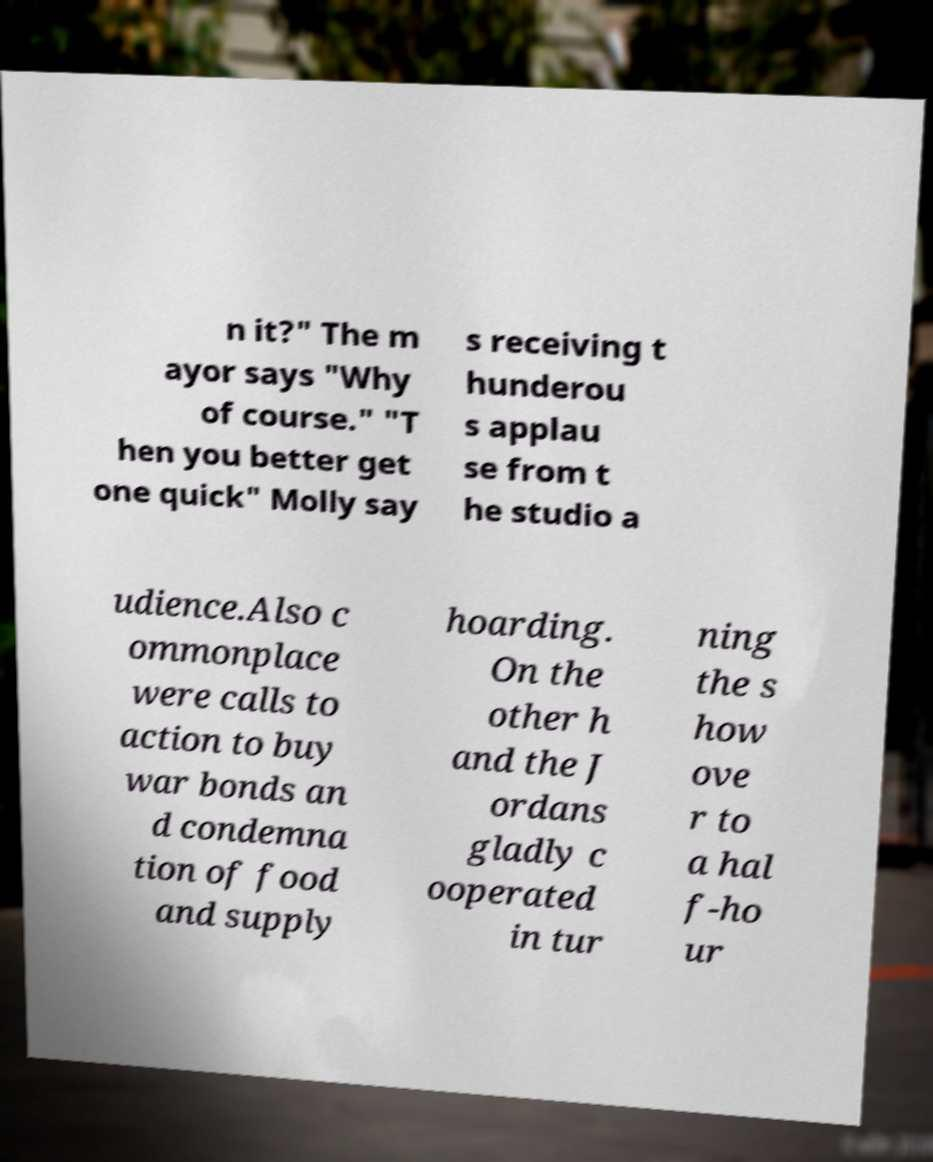Please read and relay the text visible in this image. What does it say? n it?" The m ayor says "Why of course." "T hen you better get one quick" Molly say s receiving t hunderou s applau se from t he studio a udience.Also c ommonplace were calls to action to buy war bonds an d condemna tion of food and supply hoarding. On the other h and the J ordans gladly c ooperated in tur ning the s how ove r to a hal f-ho ur 